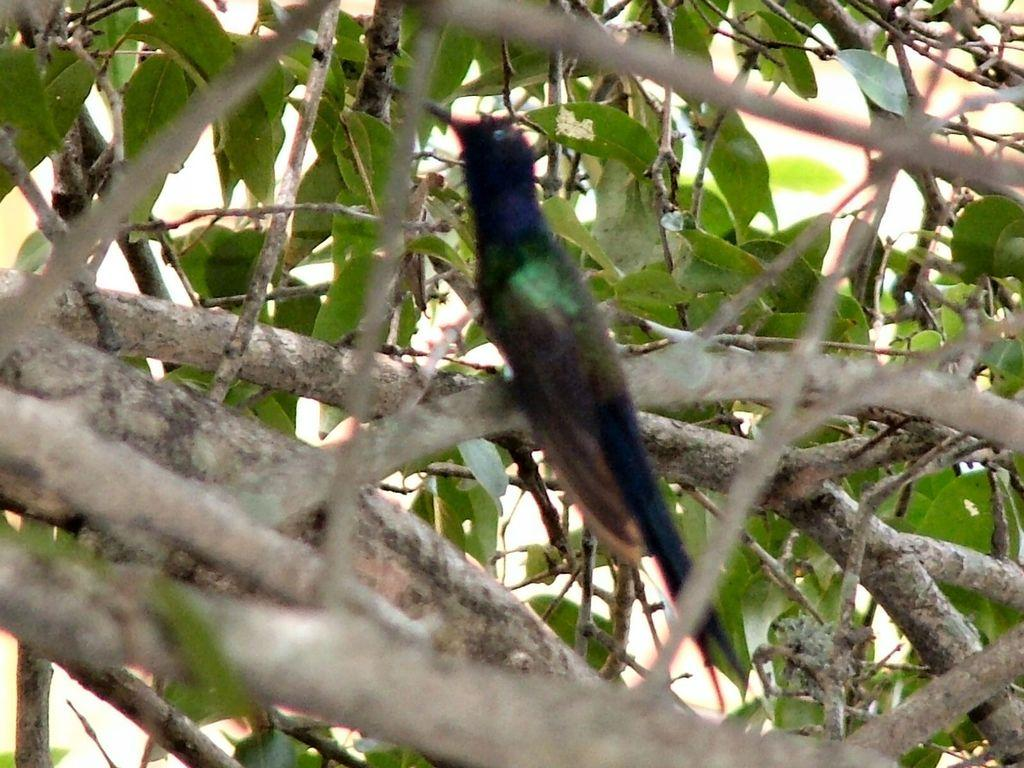What type of animal can be seen in the image? There is a bird in the image. Where is the bird located in the image? The bird is on the branch of a tree. What type of fact can be seen in the image? There is no fact present in the image; it features a bird on the branch of a tree. What color is the bird's shade of feathers in the image? The facts provided do not mention the color of the bird's feathers, so it cannot be determined from the image. 